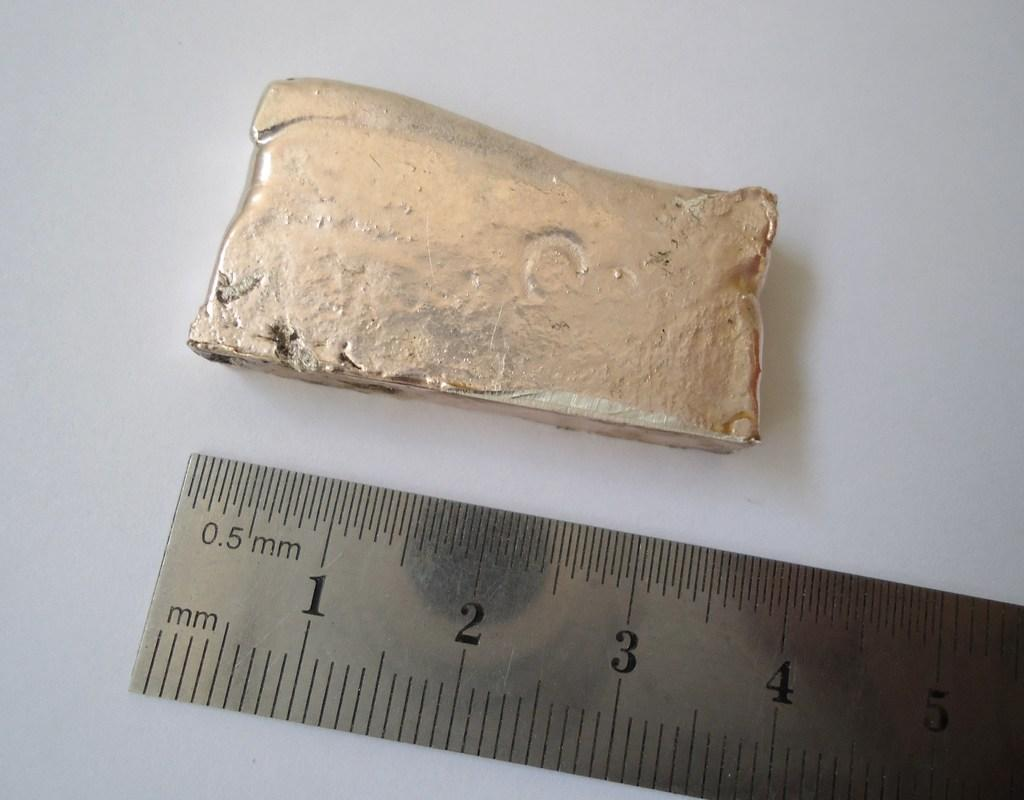<image>
Give a short and clear explanation of the subsequent image. A piece of artifact with a scale with metric measurement. 